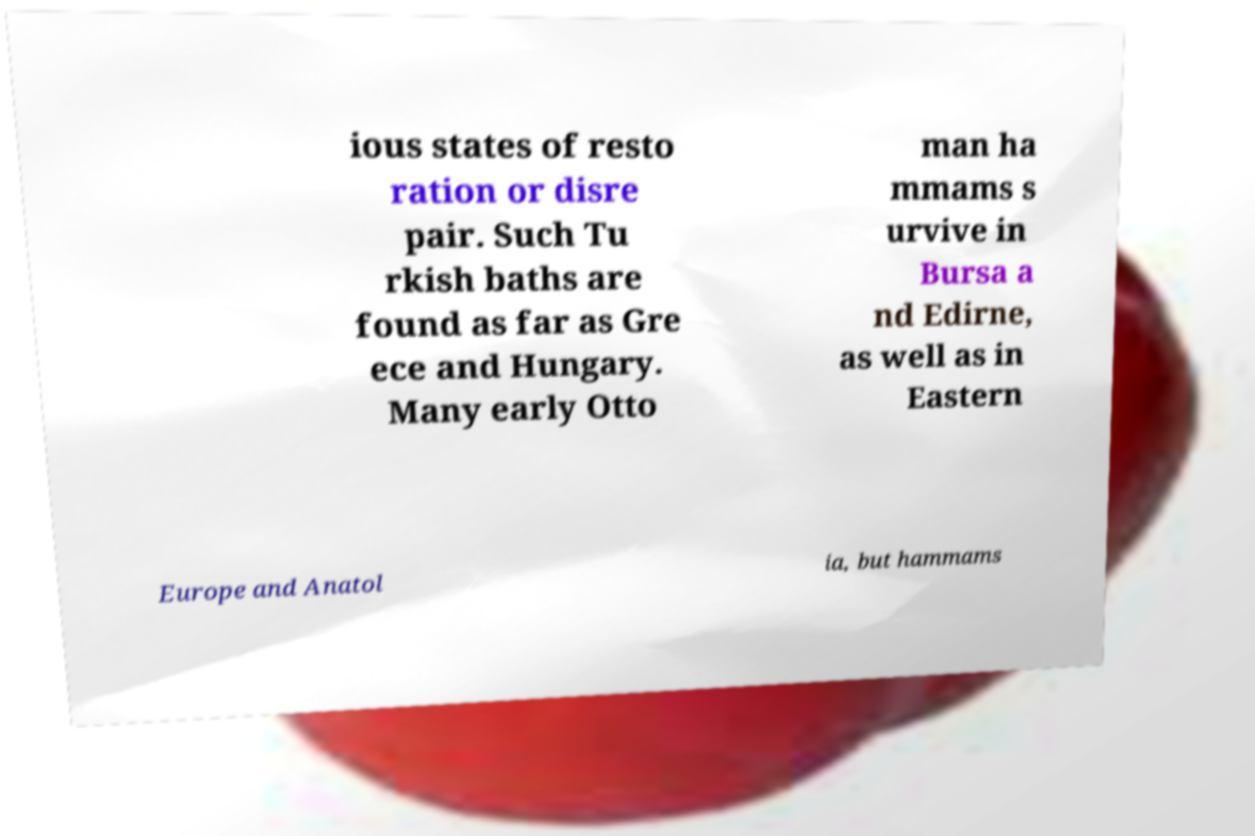What messages or text are displayed in this image? I need them in a readable, typed format. ious states of resto ration or disre pair. Such Tu rkish baths are found as far as Gre ece and Hungary. Many early Otto man ha mmams s urvive in Bursa a nd Edirne, as well as in Eastern Europe and Anatol ia, but hammams 